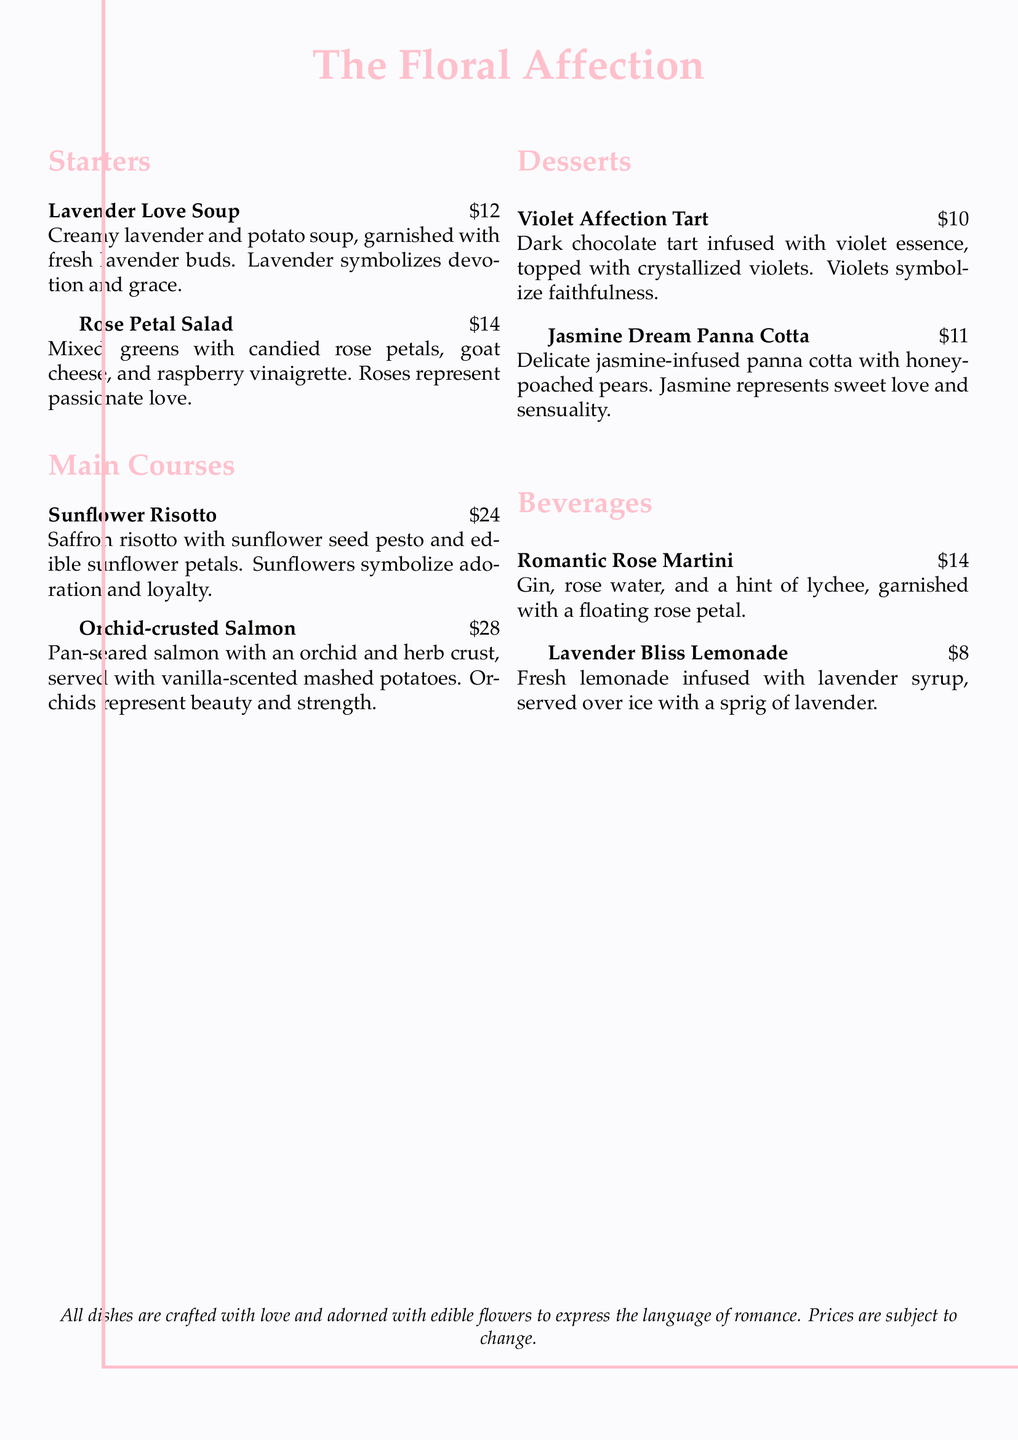What is the price of Lavender Love Soup? The price of Lavender Love Soup is explicitly listed in the document.
Answer: $12 What does lavender symbolize? The document states the symbolism associated with lavender in the Lavender Love Soup description.
Answer: devotion and grace Which dish contains candied rose petals? The dish containing candied rose petals is mentioned in the Rose Petal Salad description.
Answer: Rose Petal Salad How many main courses are listed on the menu? The main course section has two dishes listed, indicating the total count.
Answer: 2 What flower symbolizes adoration? The document specifies which flower represents adoration in the Sunflower Risotto description.
Answer: Sunflower What is the total cost of Violet Affection Tart and Jasmine Dream Panna Cotta? The total cost can be calculated by adding the prices of both desserts listed in the menu.
Answer: $21 Which beverage is garnished with a floating rose petal? The description in the menu indicates that the Romantic Rose Martini is garnished this way.
Answer: Romantic Rose Martini What does the Jasmine flower represent? The meaning of jasmine is provided in the description of Jasmine Dream Panna Cotta.
Answer: sweet love and sensuality 